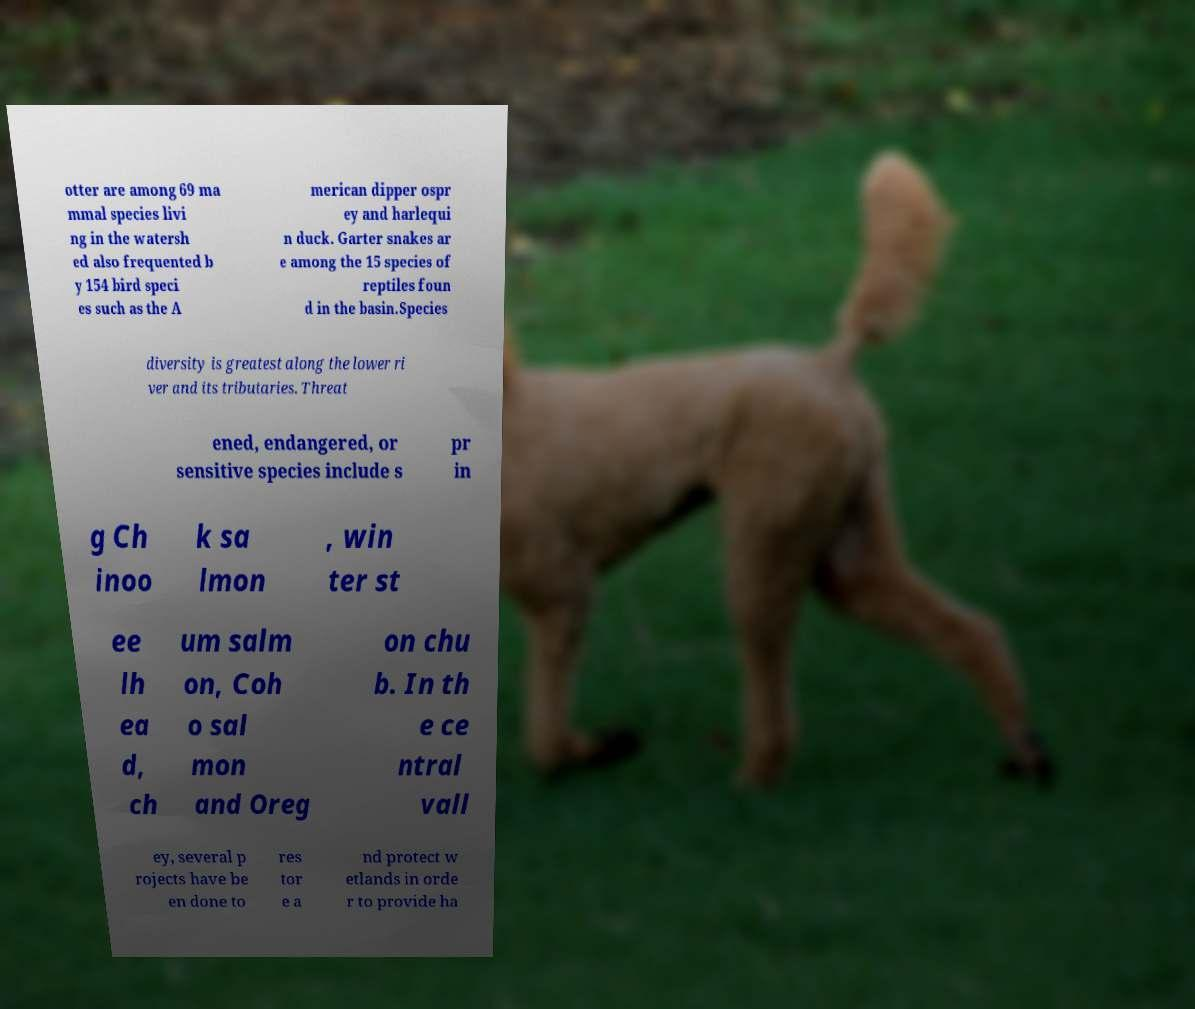I need the written content from this picture converted into text. Can you do that? otter are among 69 ma mmal species livi ng in the watersh ed also frequented b y 154 bird speci es such as the A merican dipper ospr ey and harlequi n duck. Garter snakes ar e among the 15 species of reptiles foun d in the basin.Species diversity is greatest along the lower ri ver and its tributaries. Threat ened, endangered, or sensitive species include s pr in g Ch inoo k sa lmon , win ter st ee lh ea d, ch um salm on, Coh o sal mon and Oreg on chu b. In th e ce ntral vall ey, several p rojects have be en done to res tor e a nd protect w etlands in orde r to provide ha 